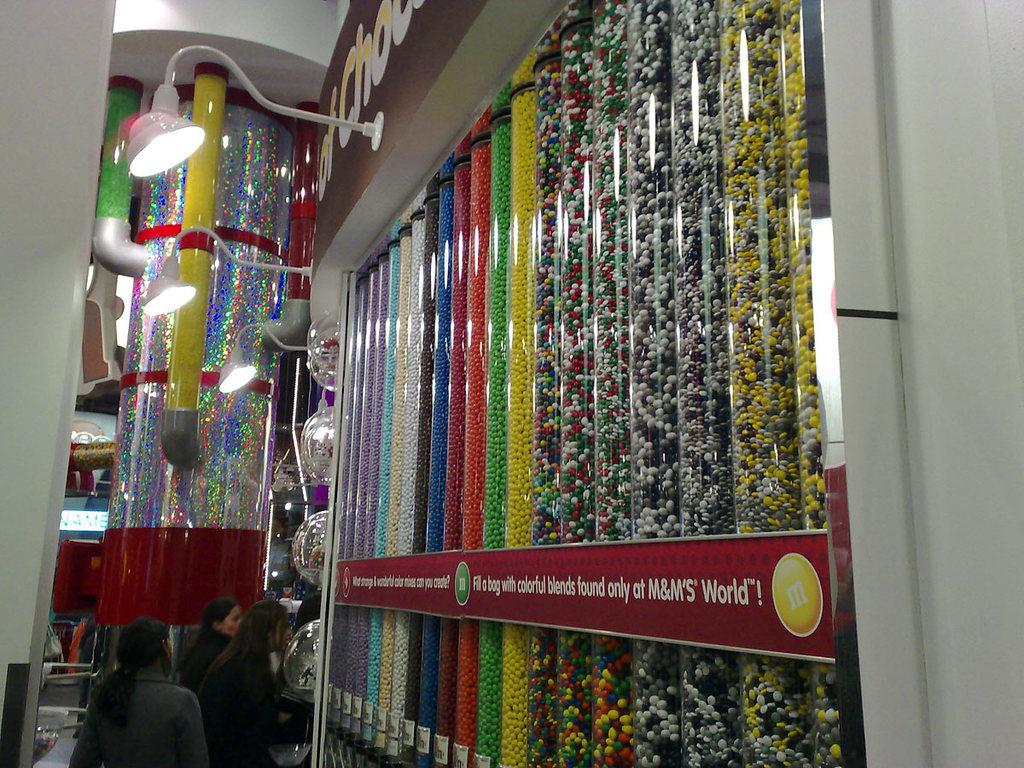<image>
Offer a succinct explanation of the picture presented. A wall of different dispenser that says Fill a bag with colorful blends found only at M&M's World. 